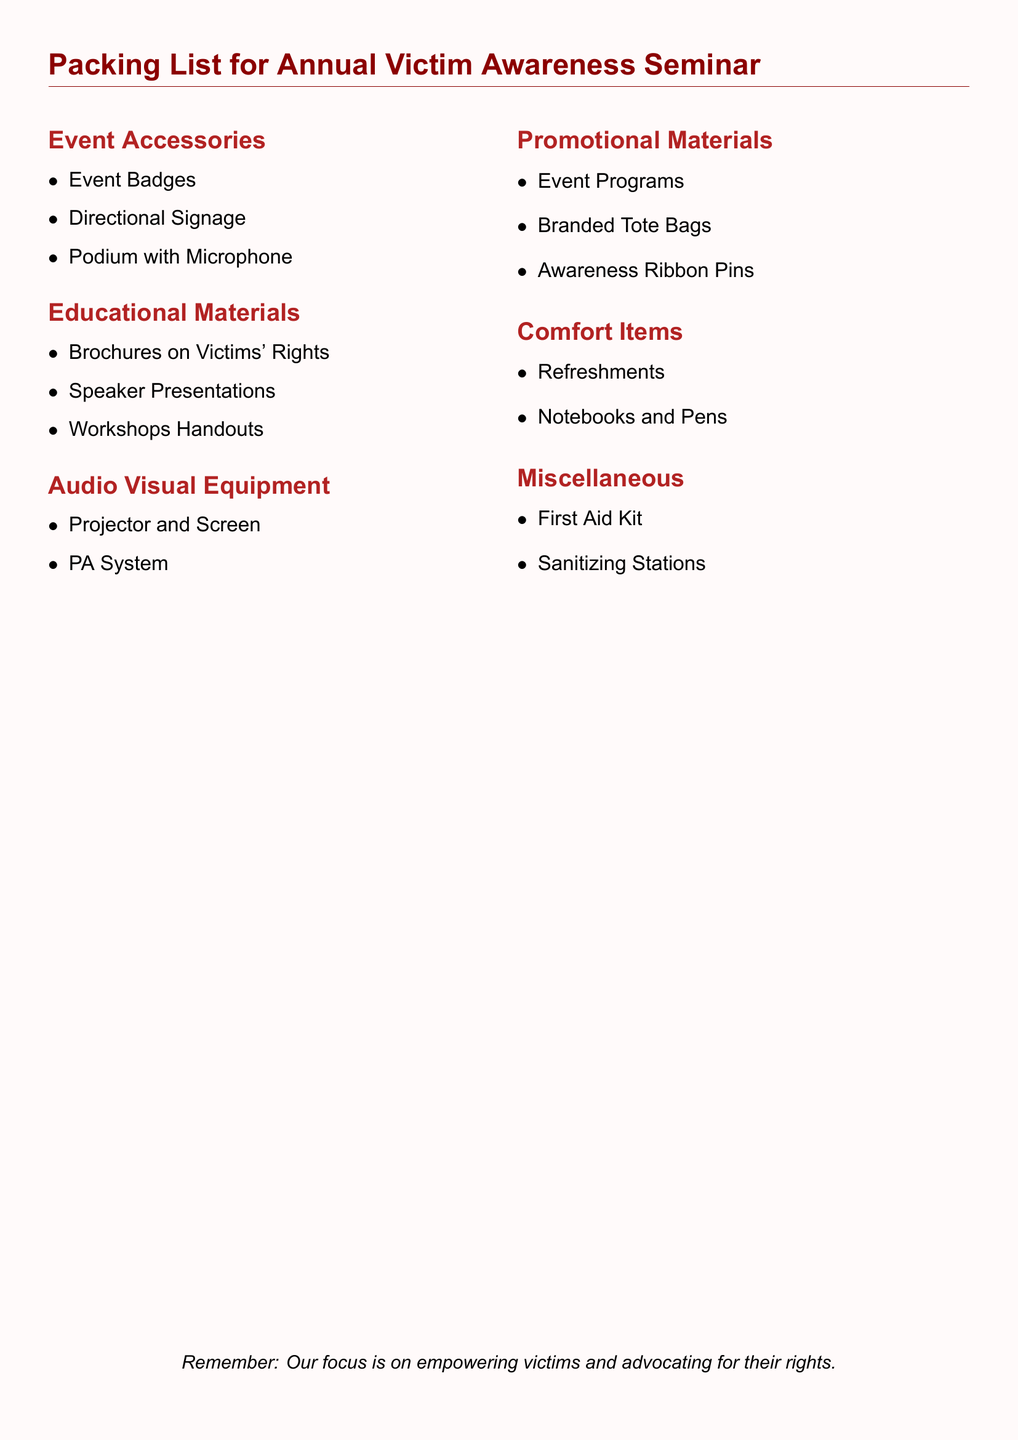What are included in the Event Accessories? This section lists specific items necessary for the seminar's organization, including badges and signage.
Answer: Event Badges, Directional Signage, Podium with Microphone How many sections are there in this packing list? The packing list contains multiple sections detailing various categories of items needed for the seminar.
Answer: Six Name one type of Educational Material listed. This category focuses on resources aimed to educate participants about victims' rights.
Answer: Brochures on Victims' Rights What type of promotional item is mentioned? This refers to materials used to raise awareness and promote the event, which is a key aspect of advocacy.
Answer: Awareness Ribbon Pins What comfort item is suggested for the seminar? The packing list includes suggestions aimed at making attendees comfortable during the event.
Answer: Refreshments 